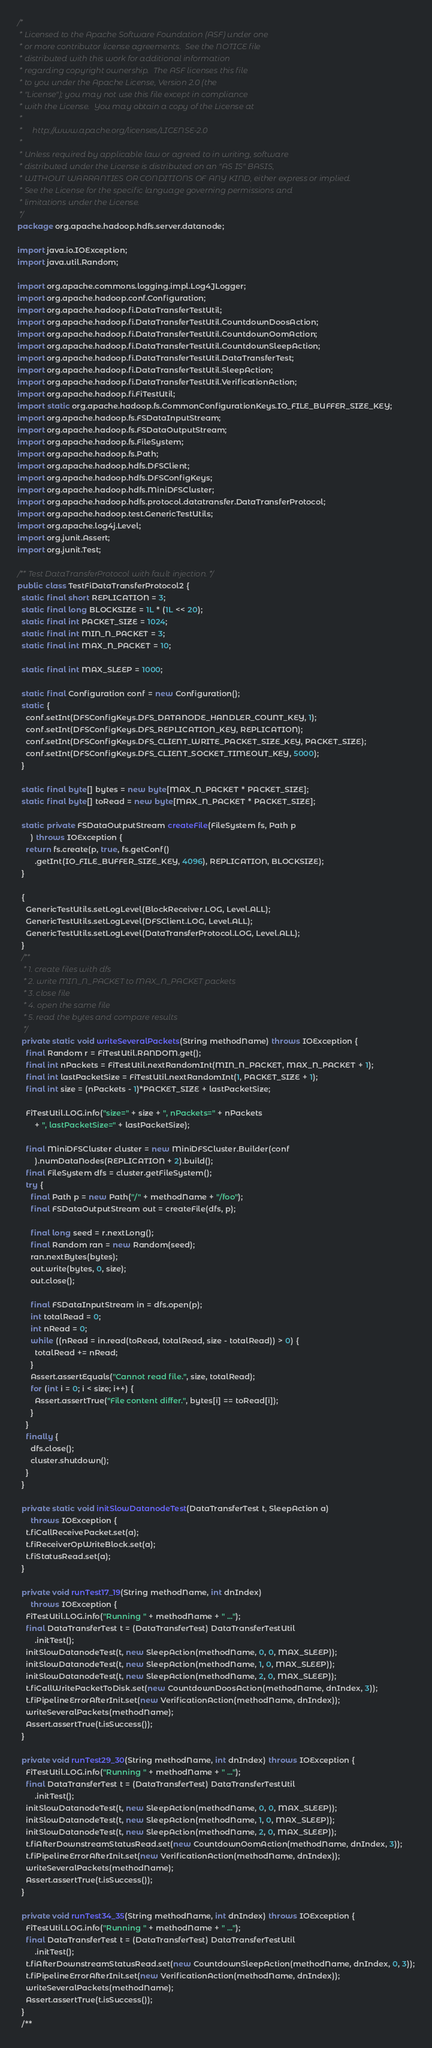<code> <loc_0><loc_0><loc_500><loc_500><_Java_>/*
 * Licensed to the Apache Software Foundation (ASF) under one
 * or more contributor license agreements.  See the NOTICE file
 * distributed with this work for additional information
 * regarding copyright ownership.  The ASF licenses this file
 * to you under the Apache License, Version 2.0 (the
 * "License"); you may not use this file except in compliance
 * with the License.  You may obtain a copy of the License at
 *
 *     http://www.apache.org/licenses/LICENSE-2.0
 *
 * Unless required by applicable law or agreed to in writing, software
 * distributed under the License is distributed on an "AS IS" BASIS,
 * WITHOUT WARRANTIES OR CONDITIONS OF ANY KIND, either express or implied.
 * See the License for the specific language governing permissions and
 * limitations under the License.
 */
package org.apache.hadoop.hdfs.server.datanode;

import java.io.IOException;
import java.util.Random;

import org.apache.commons.logging.impl.Log4JLogger;
import org.apache.hadoop.conf.Configuration;
import org.apache.hadoop.fi.DataTransferTestUtil;
import org.apache.hadoop.fi.DataTransferTestUtil.CountdownDoosAction;
import org.apache.hadoop.fi.DataTransferTestUtil.CountdownOomAction;
import org.apache.hadoop.fi.DataTransferTestUtil.CountdownSleepAction;
import org.apache.hadoop.fi.DataTransferTestUtil.DataTransferTest;
import org.apache.hadoop.fi.DataTransferTestUtil.SleepAction;
import org.apache.hadoop.fi.DataTransferTestUtil.VerificationAction;
import org.apache.hadoop.fi.FiTestUtil;
import static org.apache.hadoop.fs.CommonConfigurationKeys.IO_FILE_BUFFER_SIZE_KEY;
import org.apache.hadoop.fs.FSDataInputStream;
import org.apache.hadoop.fs.FSDataOutputStream;
import org.apache.hadoop.fs.FileSystem;
import org.apache.hadoop.fs.Path;
import org.apache.hadoop.hdfs.DFSClient;
import org.apache.hadoop.hdfs.DFSConfigKeys;
import org.apache.hadoop.hdfs.MiniDFSCluster;
import org.apache.hadoop.hdfs.protocol.datatransfer.DataTransferProtocol;
import org.apache.hadoop.test.GenericTestUtils;
import org.apache.log4j.Level;
import org.junit.Assert;
import org.junit.Test;

/** Test DataTransferProtocol with fault injection. */
public class TestFiDataTransferProtocol2 {
  static final short REPLICATION = 3;
  static final long BLOCKSIZE = 1L * (1L << 20);
  static final int PACKET_SIZE = 1024;
  static final int MIN_N_PACKET = 3;
  static final int MAX_N_PACKET = 10;

  static final int MAX_SLEEP = 1000;

  static final Configuration conf = new Configuration();
  static {
    conf.setInt(DFSConfigKeys.DFS_DATANODE_HANDLER_COUNT_KEY, 1);
    conf.setInt(DFSConfigKeys.DFS_REPLICATION_KEY, REPLICATION);
    conf.setInt(DFSConfigKeys.DFS_CLIENT_WRITE_PACKET_SIZE_KEY, PACKET_SIZE);
    conf.setInt(DFSConfigKeys.DFS_CLIENT_SOCKET_TIMEOUT_KEY, 5000);
  }

  static final byte[] bytes = new byte[MAX_N_PACKET * PACKET_SIZE];
  static final byte[] toRead = new byte[MAX_N_PACKET * PACKET_SIZE];

  static private FSDataOutputStream createFile(FileSystem fs, Path p
      ) throws IOException {
    return fs.create(p, true, fs.getConf()
        .getInt(IO_FILE_BUFFER_SIZE_KEY, 4096), REPLICATION, BLOCKSIZE);
  }

  {
    GenericTestUtils.setLogLevel(BlockReceiver.LOG, Level.ALL);
    GenericTestUtils.setLogLevel(DFSClient.LOG, Level.ALL);
    GenericTestUtils.setLogLevel(DataTransferProtocol.LOG, Level.ALL);
  }
  /**
   * 1. create files with dfs
   * 2. write MIN_N_PACKET to MAX_N_PACKET packets
   * 3. close file
   * 4. open the same file
   * 5. read the bytes and compare results
   */
  private static void writeSeveralPackets(String methodName) throws IOException {
    final Random r = FiTestUtil.RANDOM.get();
    final int nPackets = FiTestUtil.nextRandomInt(MIN_N_PACKET, MAX_N_PACKET + 1);
    final int lastPacketSize = FiTestUtil.nextRandomInt(1, PACKET_SIZE + 1);
    final int size = (nPackets - 1)*PACKET_SIZE + lastPacketSize;

    FiTestUtil.LOG.info("size=" + size + ", nPackets=" + nPackets
        + ", lastPacketSize=" + lastPacketSize);

    final MiniDFSCluster cluster = new MiniDFSCluster.Builder(conf
        ).numDataNodes(REPLICATION + 2).build();
    final FileSystem dfs = cluster.getFileSystem();
    try {
      final Path p = new Path("/" + methodName + "/foo");
      final FSDataOutputStream out = createFile(dfs, p);

      final long seed = r.nextLong();
      final Random ran = new Random(seed);
      ran.nextBytes(bytes);
      out.write(bytes, 0, size);
      out.close();

      final FSDataInputStream in = dfs.open(p);
      int totalRead = 0;
      int nRead = 0;
      while ((nRead = in.read(toRead, totalRead, size - totalRead)) > 0) {
        totalRead += nRead;
      }
      Assert.assertEquals("Cannot read file.", size, totalRead);
      for (int i = 0; i < size; i++) {
        Assert.assertTrue("File content differ.", bytes[i] == toRead[i]);
      }
    }
    finally {
      dfs.close();
      cluster.shutdown();
    }
  }

  private static void initSlowDatanodeTest(DataTransferTest t, SleepAction a)
      throws IOException {
    t.fiCallReceivePacket.set(a);
    t.fiReceiverOpWriteBlock.set(a);
    t.fiStatusRead.set(a);
  }

  private void runTest17_19(String methodName, int dnIndex)
      throws IOException {
    FiTestUtil.LOG.info("Running " + methodName + " ...");
    final DataTransferTest t = (DataTransferTest) DataTransferTestUtil
        .initTest();
    initSlowDatanodeTest(t, new SleepAction(methodName, 0, 0, MAX_SLEEP));
    initSlowDatanodeTest(t, new SleepAction(methodName, 1, 0, MAX_SLEEP));
    initSlowDatanodeTest(t, new SleepAction(methodName, 2, 0, MAX_SLEEP));
    t.fiCallWritePacketToDisk.set(new CountdownDoosAction(methodName, dnIndex, 3));
    t.fiPipelineErrorAfterInit.set(new VerificationAction(methodName, dnIndex));
    writeSeveralPackets(methodName);
    Assert.assertTrue(t.isSuccess());
  }

  private void runTest29_30(String methodName, int dnIndex) throws IOException {
    FiTestUtil.LOG.info("Running " + methodName + " ...");
    final DataTransferTest t = (DataTransferTest) DataTransferTestUtil
        .initTest();
    initSlowDatanodeTest(t, new SleepAction(methodName, 0, 0, MAX_SLEEP));
    initSlowDatanodeTest(t, new SleepAction(methodName, 1, 0, MAX_SLEEP));
    initSlowDatanodeTest(t, new SleepAction(methodName, 2, 0, MAX_SLEEP));
    t.fiAfterDownstreamStatusRead.set(new CountdownOomAction(methodName, dnIndex, 3));
    t.fiPipelineErrorAfterInit.set(new VerificationAction(methodName, dnIndex));
    writeSeveralPackets(methodName);
    Assert.assertTrue(t.isSuccess());
  }
  
  private void runTest34_35(String methodName, int dnIndex) throws IOException {
    FiTestUtil.LOG.info("Running " + methodName + " ...");
    final DataTransferTest t = (DataTransferTest) DataTransferTestUtil
        .initTest();
    t.fiAfterDownstreamStatusRead.set(new CountdownSleepAction(methodName, dnIndex, 0, 3));
    t.fiPipelineErrorAfterInit.set(new VerificationAction(methodName, dnIndex));
    writeSeveralPackets(methodName);
    Assert.assertTrue(t.isSuccess());
  }
  /**</code> 